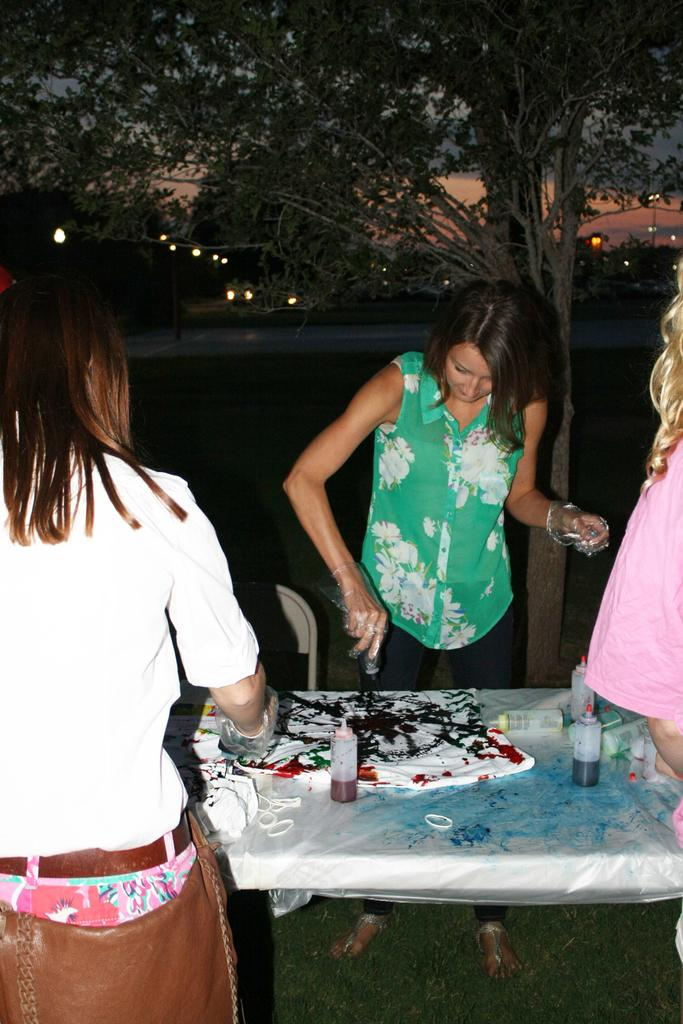Who is present in the image? There is a woman in the image. What is the woman wearing? The woman is wearing a green dress. How is the woman described? The woman is described as stunning. What can be seen in the image besides the woman? There are bottles with colors and a t-shirt on the table in the image. What is visible in the background of the image? There is a tree visible in the background of the image. What shape is the stage in the image? There is no stage present in the image. How many bushes are visible in the image? There are no bushes visible in the image; only a tree is mentioned in the background. 